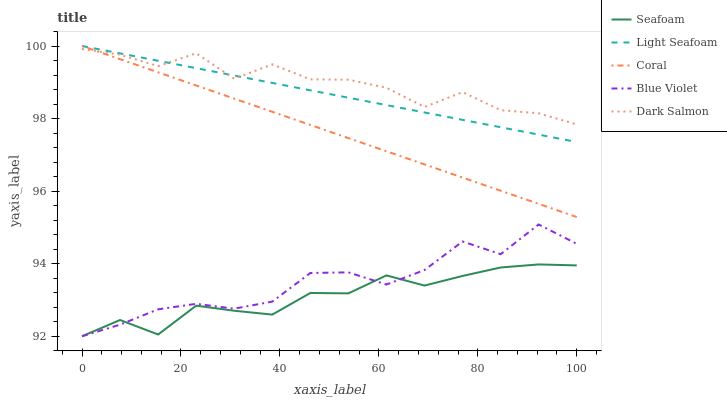Does Seafoam have the minimum area under the curve?
Answer yes or no. Yes. Does Dark Salmon have the maximum area under the curve?
Answer yes or no. Yes. Does Light Seafoam have the minimum area under the curve?
Answer yes or no. No. Does Light Seafoam have the maximum area under the curve?
Answer yes or no. No. Is Light Seafoam the smoothest?
Answer yes or no. Yes. Is Blue Violet the roughest?
Answer yes or no. Yes. Is Seafoam the smoothest?
Answer yes or no. No. Is Seafoam the roughest?
Answer yes or no. No. Does Light Seafoam have the lowest value?
Answer yes or no. No. Does Seafoam have the highest value?
Answer yes or no. No. Is Seafoam less than Dark Salmon?
Answer yes or no. Yes. Is Light Seafoam greater than Seafoam?
Answer yes or no. Yes. Does Seafoam intersect Dark Salmon?
Answer yes or no. No. 